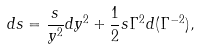<formula> <loc_0><loc_0><loc_500><loc_500>d s = \frac { s } { y ^ { 2 } } d y ^ { 2 } + \frac { 1 } { 2 } s \Gamma ^ { 2 } d ( \Gamma ^ { - 2 } ) ,</formula> 